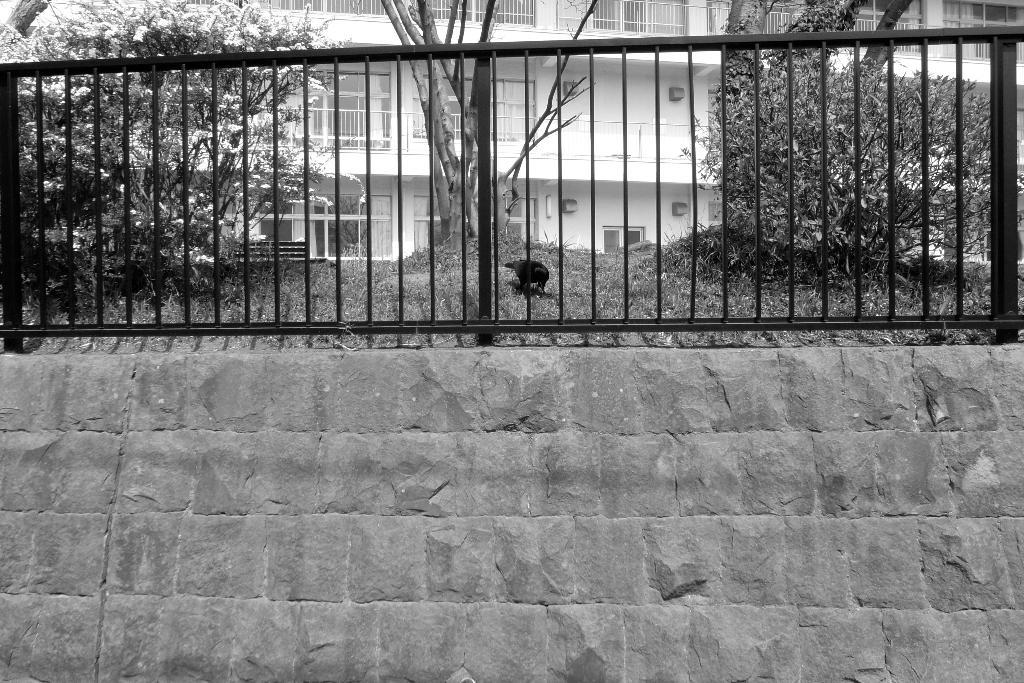What is the color scheme of the image? The image is black and white. What type of structure can be seen in the image? There is a wall, a fence, a building, and windows in the image. What is the bird's location in the image? The bird is on the grass in the image. What other elements are present in the image? There are plants, a grille, a bench, and a building in the image. What type of smell can be detected in the image? There is no information about smells in the image, as it is a visual medium. Is there a roof visible in the image? There is no mention of a roof in the provided facts, so it cannot be determined if one is present in the image. 